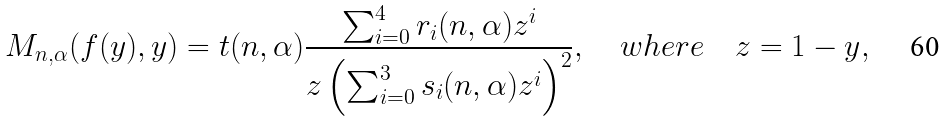Convert formula to latex. <formula><loc_0><loc_0><loc_500><loc_500>M _ { n , \alpha } ( f ( y ) , y ) = t ( n , \alpha ) \frac { \sum _ { i = 0 } ^ { 4 } r _ { i } ( n , \alpha ) z ^ { i } } { z \left ( \sum _ { i = 0 } ^ { 3 } s _ { i } ( n , \alpha ) z ^ { i } \right ) ^ { 2 } } , \quad w h e r e \quad z = 1 - y ,</formula> 